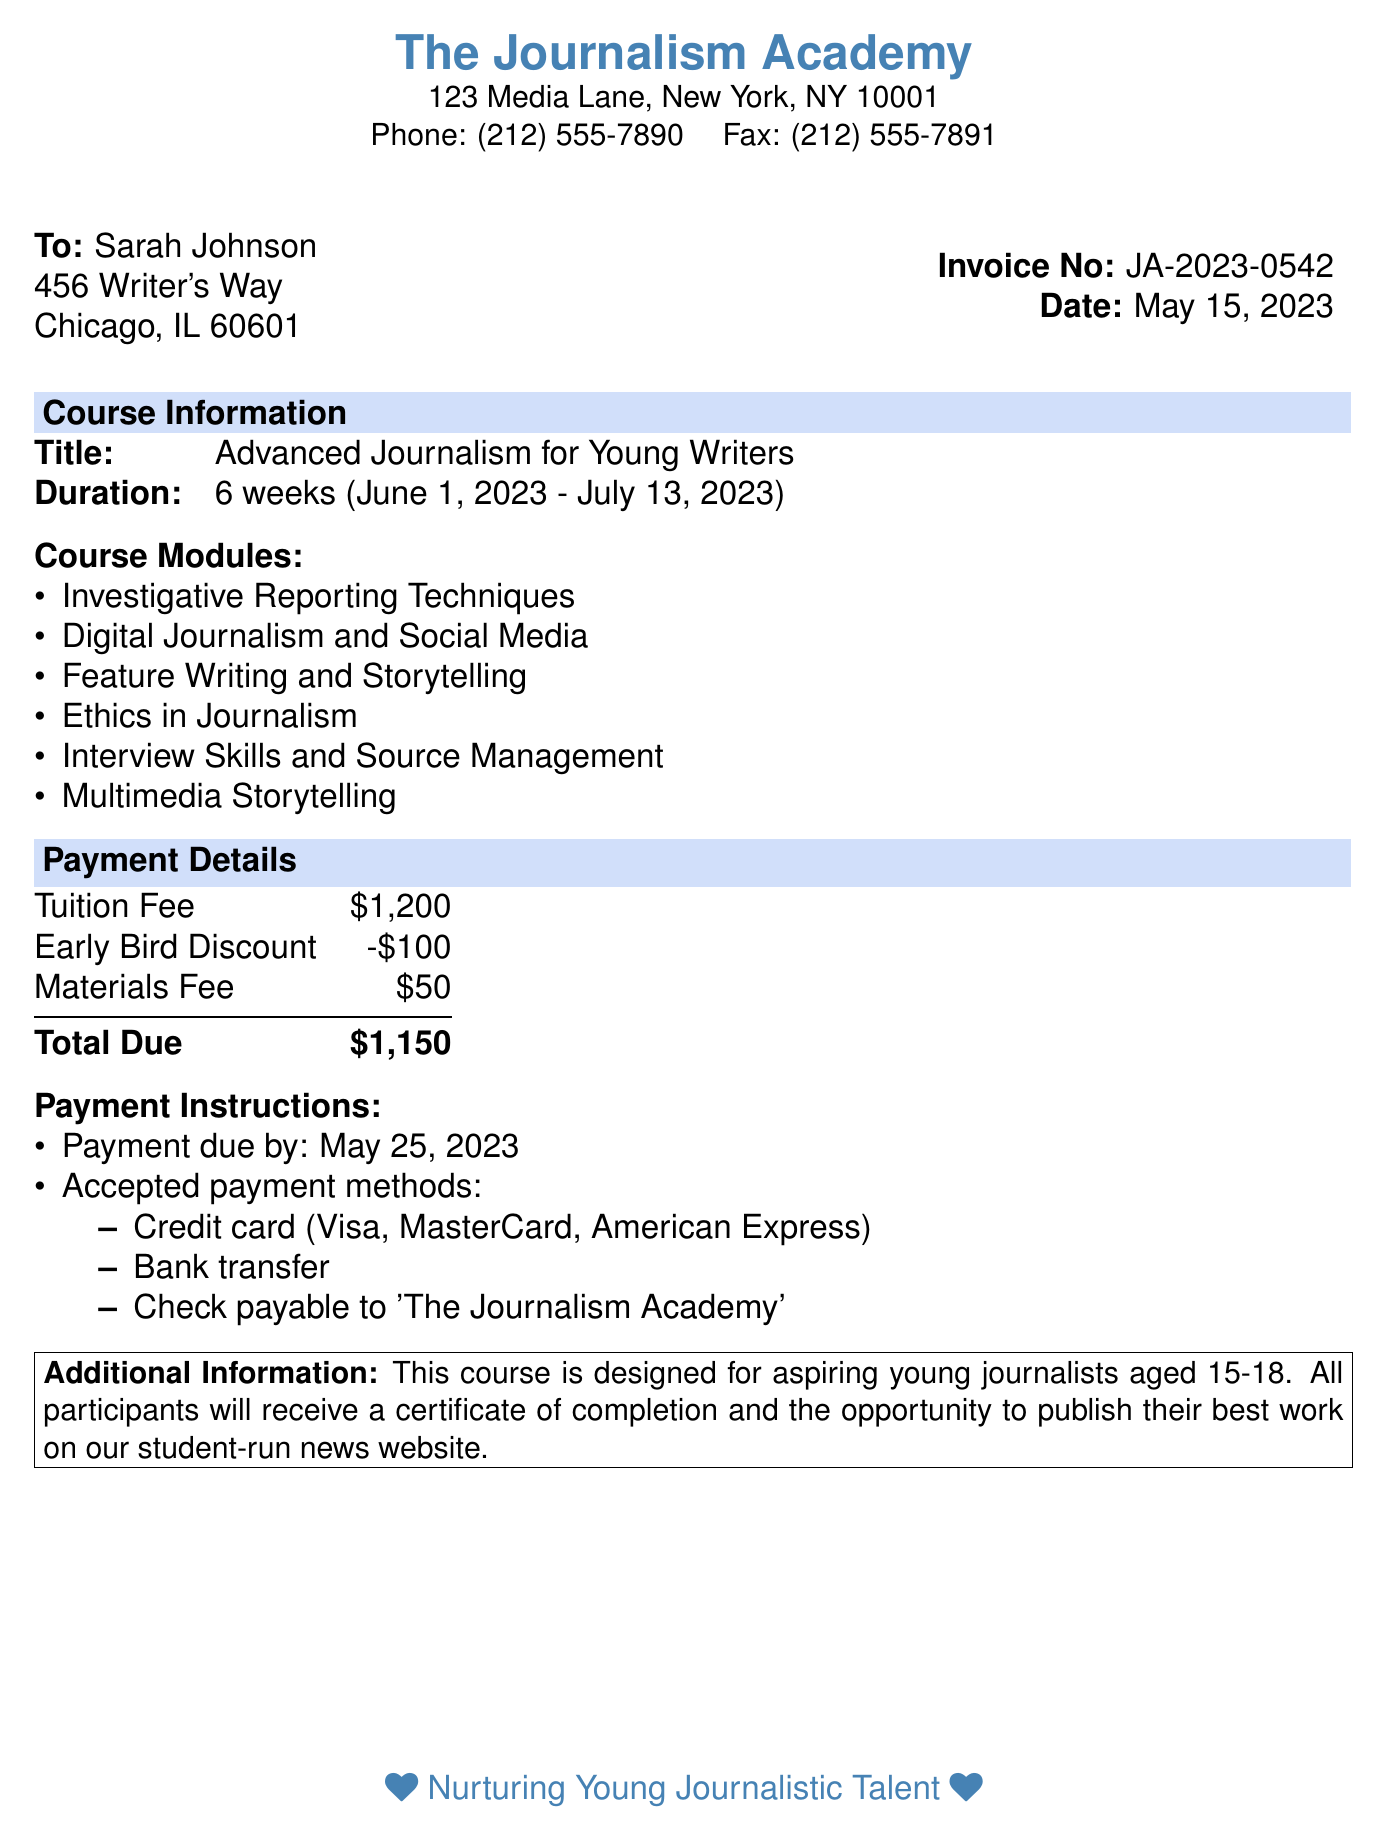What is the title of the course? The title of the course can be found in the document under the course information section.
Answer: Advanced Journalism for Young Writers What are the dates for the course duration? The document provides the start and end dates of the course under the course information section.
Answer: June 1, 2023 - July 13, 2023 How many modules are included in the course? The total number of modules is listed in the course modules section of the document.
Answer: Six What is the total amount due for the course? The total amount due is summed from the tuition fee and additional fees listed under payment details.
Answer: $1,150 What is the early bird discount amount? The early bird discount is specified as a deduction from the tuition fee in the payment details section.
Answer: $100 By what date is the payment due? The due date for the payment is explicitly mentioned in the payment instructions section of the document.
Answer: May 25, 2023 What age group is the course designed for? The target age group for the course is noted in the additional information section at the bottom of the document.
Answer: 15-18 Which payment methods are accepted? Accepted payment methods are enumerated in the payment instructions section of the document.
Answer: Credit card, Bank transfer, Check What additional opportunity do participants receive? The additional opportunity given to participants is described in the additional information section at the end of the document.
Answer: Publish their best work on our student-run news website 